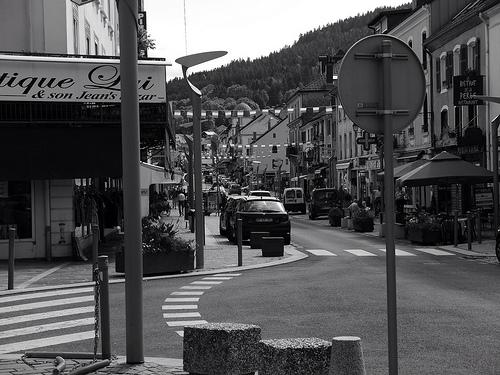Question: how is the picture taken?
Choices:
A. Color.
B. Black and white.
C. Film.
D. Digital.
Answer with the letter. Answer: B Question: what is in the background?
Choices:
A. Desert.
B. Mountain.
C. Grass.
D. Forest.
Answer with the letter. Answer: B 